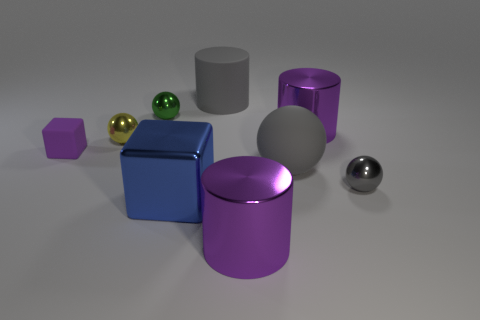There is a matte thing that is the same size as the gray matte cylinder; what is its shape?
Offer a very short reply. Sphere. Are there any other things that have the same color as the small matte block?
Provide a succinct answer. Yes. What size is the green object that is the same material as the tiny yellow thing?
Keep it short and to the point. Small. Do the large blue metallic thing and the purple object in front of the tiny gray shiny sphere have the same shape?
Provide a succinct answer. No. The green metallic ball is what size?
Provide a short and direct response. Small. Are there fewer small cubes left of the tiny rubber cube than yellow metallic balls?
Your answer should be compact. Yes. What number of green shiny things are the same size as the blue cube?
Your response must be concise. 0. What shape is the small metal thing that is the same color as the matte ball?
Give a very brief answer. Sphere. Do the block that is on the left side of the tiny green metallic sphere and the large metal cylinder behind the tiny gray metal ball have the same color?
Make the answer very short. Yes. There is a yellow ball; how many big rubber objects are behind it?
Offer a very short reply. 1. 